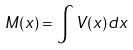<formula> <loc_0><loc_0><loc_500><loc_500>M ( x ) = \int V ( x ) d x</formula> 